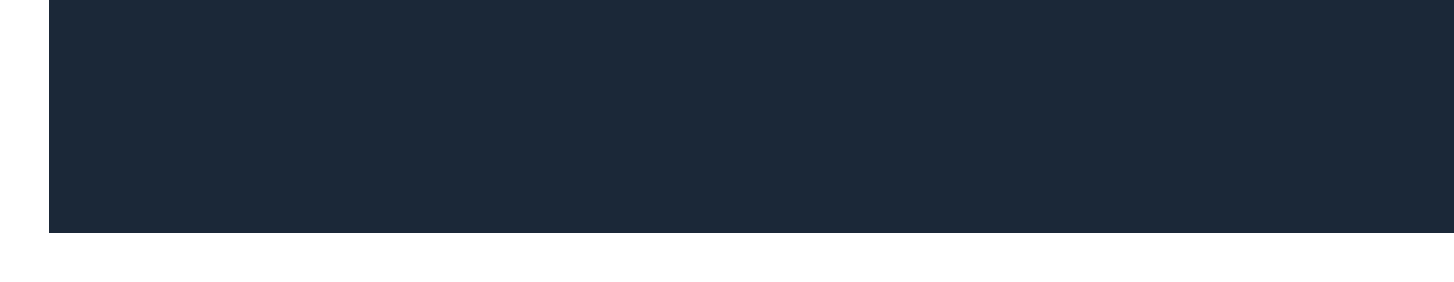What is the sender's name? The sender of the email is identified in the document as "Steam Support."
Answer: Steam Support What new security feature is mandatory for all accounts? The document mentions that "Two-Factor Authentication (2FA) is now mandatory for all accounts."
Answer: Two-Factor Authentication (2FA) What should users navigate to in order to adjust their settings? According to the document, users need to navigate to "Account Settings" to review and adjust their new security and privacy options.
Answer: Account Settings How many security updates are listed in the document? There are three security updates mentioned in the document, which are 1) Two-Factor Authentication, 2) New IP address verification, and 3) Enhanced password strength requirements.
Answer: 3 What is one of the upcoming features mentioned? The document states that one of the upcoming features is "Cross-platform cloud saves for select games."
Answer: Cross-platform cloud saves What is the purpose of the email? The email is intended to inform users about "recent updates to your Steam account, including new security features and privacy settings."
Answer: Important updates to your Steam account What does the document thank users for? The closing statement in the document thanks users for "being a part of the Steam community."
Answer: Being a part of the Steam community What can users do with the new friends list management tools? The document includes "New friends list management tools" under privacy settings, which allows users to better manage their friends list.
Answer: Manage their friends list What is the footer about? The footer of the document provides information on where to find more details, stating "For more information, visit our FAQ page or contact Steam Support."
Answer: FAQ page or contact Steam Support 